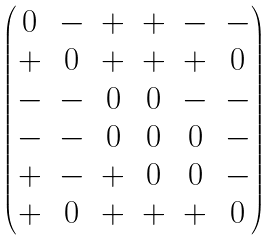Convert formula to latex. <formula><loc_0><loc_0><loc_500><loc_500>\begin{pmatrix} 0 & - & + & + & - & - \\ + & 0 & + & + & + & 0 \\ - & - & 0 & 0 & - & - \\ - & - & 0 & 0 & 0 & - \\ + & - & + & 0 & 0 & - \\ + & 0 & + & + & + & 0 \end{pmatrix}</formula> 